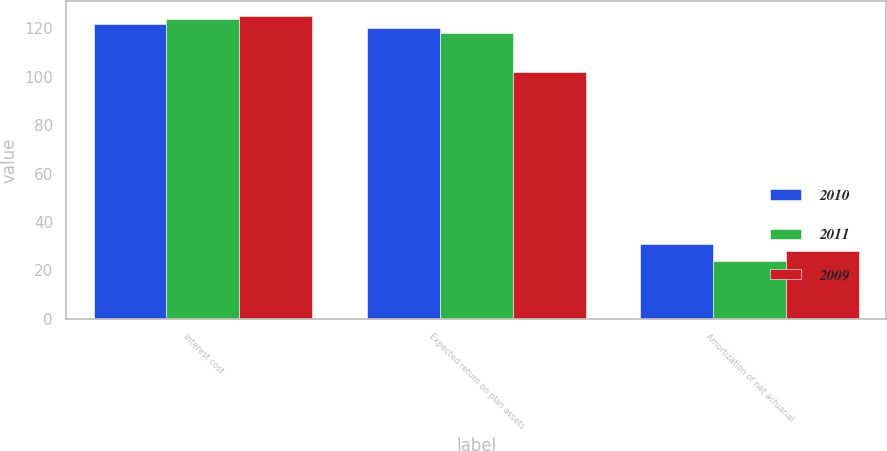Convert chart. <chart><loc_0><loc_0><loc_500><loc_500><stacked_bar_chart><ecel><fcel>Interest cost<fcel>Expected return on plan assets<fcel>Amortization of net actuarial<nl><fcel>2010<fcel>122<fcel>120<fcel>31<nl><fcel>2011<fcel>124<fcel>118<fcel>24<nl><fcel>2009<fcel>125<fcel>102<fcel>28<nl></chart> 